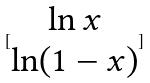<formula> <loc_0><loc_0><loc_500><loc_500>[ \begin{matrix} \ln x \\ \ln ( 1 - x ) \end{matrix} ]</formula> 